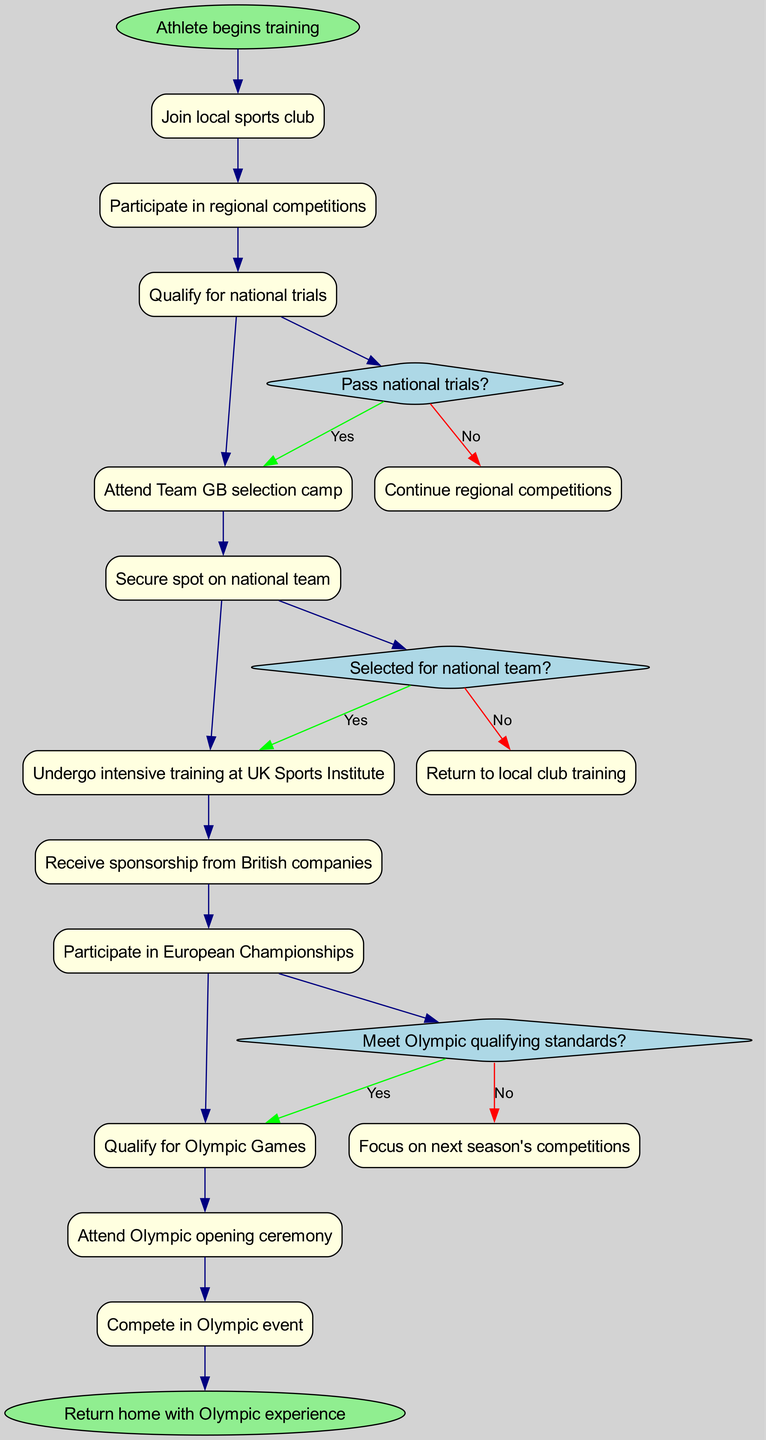What is the first activity in the athlete's journey? The first activity listed in the diagram is "Join local sports club," which is connected directly from the "Athlete begins training" start node.
Answer: Join local sports club What decision follows after participating in regional competitions? After "Participate in regional competitions," the next step is to ask the question "Pass national trials?" which is indicated as a decision point.
Answer: Pass national trials? How many activities are listed in the diagram? The diagram contains a total of 10 activities, as enumerated from "Join local sports club" to "Compete in Olympic event."
Answer: 10 What happens if the athlete does not qualify in the national trials? If the athlete does not pass the national trials, the next step is to "Continue regional competitions" according to the decision points section of the diagram.
Answer: Continue regional competitions Which activity comes after securing a spot on the national team? The activity that follows after "Secure spot on national team" is "Undergo intensive training at UK Sports Institute," indicating the next step in the process.
Answer: Undergo intensive training at UK Sports Institute What is the outcome if the athlete meets the Olympic qualifying standards? If the athlete meets the Olympic qualifying standards, the next step in the diagram is "Qualify for Olympic Games," indicating progress towards competing in the Olympics.
Answer: Qualify for Olympic Games What decision is made before attending the Olympic opening ceremony? Before attending the Olympic opening ceremony, there must be a decision on whether the athlete has qualified for the Olympic Games, which leads to the opening ceremony if successful.
Answer: Qualified for Olympic Games How does sponsorship influence the journey of the athlete? The athlete receives sponsorship from British companies after undergoing intensive training at the UK Sports Institute, which is a key milestone that supports their journey.
Answer: Receive sponsorship from British companies What is the final node in the athlete's journey? The final node indicated in the diagram is "Return home with Olympic experience," which signifies the completion of the athlete's journey after competing.
Answer: Return home with Olympic experience 